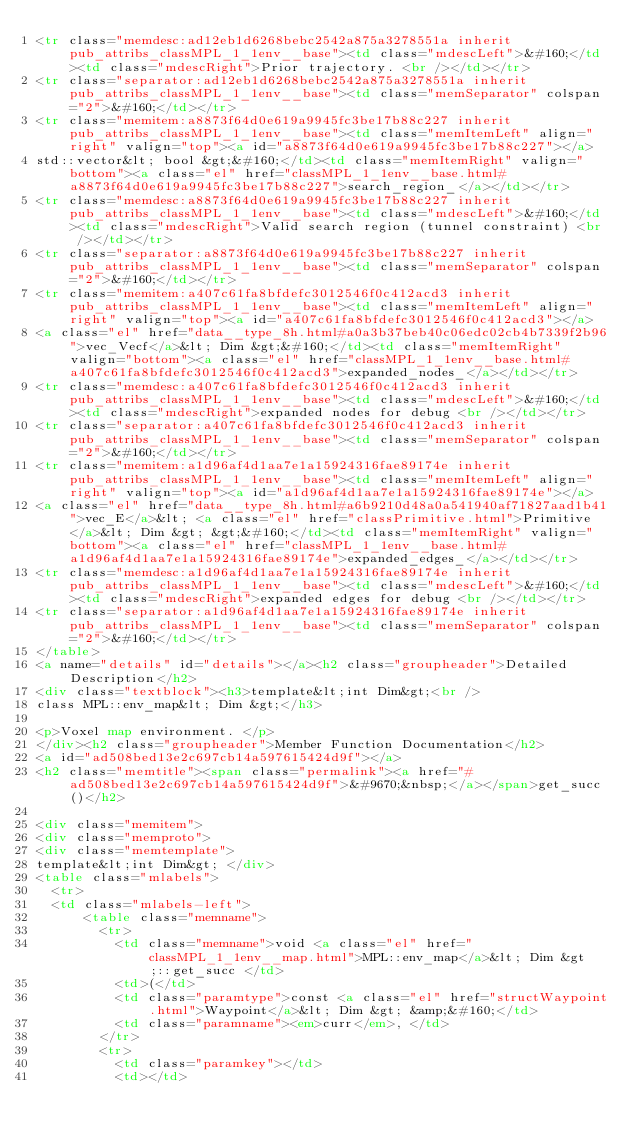Convert code to text. <code><loc_0><loc_0><loc_500><loc_500><_HTML_><tr class="memdesc:ad12eb1d6268bebc2542a875a3278551a inherit pub_attribs_classMPL_1_1env__base"><td class="mdescLeft">&#160;</td><td class="mdescRight">Prior trajectory. <br /></td></tr>
<tr class="separator:ad12eb1d6268bebc2542a875a3278551a inherit pub_attribs_classMPL_1_1env__base"><td class="memSeparator" colspan="2">&#160;</td></tr>
<tr class="memitem:a8873f64d0e619a9945fc3be17b88c227 inherit pub_attribs_classMPL_1_1env__base"><td class="memItemLeft" align="right" valign="top"><a id="a8873f64d0e619a9945fc3be17b88c227"></a>
std::vector&lt; bool &gt;&#160;</td><td class="memItemRight" valign="bottom"><a class="el" href="classMPL_1_1env__base.html#a8873f64d0e619a9945fc3be17b88c227">search_region_</a></td></tr>
<tr class="memdesc:a8873f64d0e619a9945fc3be17b88c227 inherit pub_attribs_classMPL_1_1env__base"><td class="mdescLeft">&#160;</td><td class="mdescRight">Valid search region (tunnel constraint) <br /></td></tr>
<tr class="separator:a8873f64d0e619a9945fc3be17b88c227 inherit pub_attribs_classMPL_1_1env__base"><td class="memSeparator" colspan="2">&#160;</td></tr>
<tr class="memitem:a407c61fa8bfdefc3012546f0c412acd3 inherit pub_attribs_classMPL_1_1env__base"><td class="memItemLeft" align="right" valign="top"><a id="a407c61fa8bfdefc3012546f0c412acd3"></a>
<a class="el" href="data__type_8h.html#a0a3b37beb40c06edc02cb4b7339f2b96">vec_Vecf</a>&lt; Dim &gt;&#160;</td><td class="memItemRight" valign="bottom"><a class="el" href="classMPL_1_1env__base.html#a407c61fa8bfdefc3012546f0c412acd3">expanded_nodes_</a></td></tr>
<tr class="memdesc:a407c61fa8bfdefc3012546f0c412acd3 inherit pub_attribs_classMPL_1_1env__base"><td class="mdescLeft">&#160;</td><td class="mdescRight">expanded nodes for debug <br /></td></tr>
<tr class="separator:a407c61fa8bfdefc3012546f0c412acd3 inherit pub_attribs_classMPL_1_1env__base"><td class="memSeparator" colspan="2">&#160;</td></tr>
<tr class="memitem:a1d96af4d1aa7e1a15924316fae89174e inherit pub_attribs_classMPL_1_1env__base"><td class="memItemLeft" align="right" valign="top"><a id="a1d96af4d1aa7e1a15924316fae89174e"></a>
<a class="el" href="data__type_8h.html#a6b9210d48a0a541940af71827aad1b41">vec_E</a>&lt; <a class="el" href="classPrimitive.html">Primitive</a>&lt; Dim &gt; &gt;&#160;</td><td class="memItemRight" valign="bottom"><a class="el" href="classMPL_1_1env__base.html#a1d96af4d1aa7e1a15924316fae89174e">expanded_edges_</a></td></tr>
<tr class="memdesc:a1d96af4d1aa7e1a15924316fae89174e inherit pub_attribs_classMPL_1_1env__base"><td class="mdescLeft">&#160;</td><td class="mdescRight">expanded edges for debug <br /></td></tr>
<tr class="separator:a1d96af4d1aa7e1a15924316fae89174e inherit pub_attribs_classMPL_1_1env__base"><td class="memSeparator" colspan="2">&#160;</td></tr>
</table>
<a name="details" id="details"></a><h2 class="groupheader">Detailed Description</h2>
<div class="textblock"><h3>template&lt;int Dim&gt;<br />
class MPL::env_map&lt; Dim &gt;</h3>

<p>Voxel map environment. </p>
</div><h2 class="groupheader">Member Function Documentation</h2>
<a id="ad508bed13e2c697cb14a597615424d9f"></a>
<h2 class="memtitle"><span class="permalink"><a href="#ad508bed13e2c697cb14a597615424d9f">&#9670;&nbsp;</a></span>get_succ()</h2>

<div class="memitem">
<div class="memproto">
<div class="memtemplate">
template&lt;int Dim&gt; </div>
<table class="mlabels">
  <tr>
  <td class="mlabels-left">
      <table class="memname">
        <tr>
          <td class="memname">void <a class="el" href="classMPL_1_1env__map.html">MPL::env_map</a>&lt; Dim &gt;::get_succ </td>
          <td>(</td>
          <td class="paramtype">const <a class="el" href="structWaypoint.html">Waypoint</a>&lt; Dim &gt; &amp;&#160;</td>
          <td class="paramname"><em>curr</em>, </td>
        </tr>
        <tr>
          <td class="paramkey"></td>
          <td></td></code> 